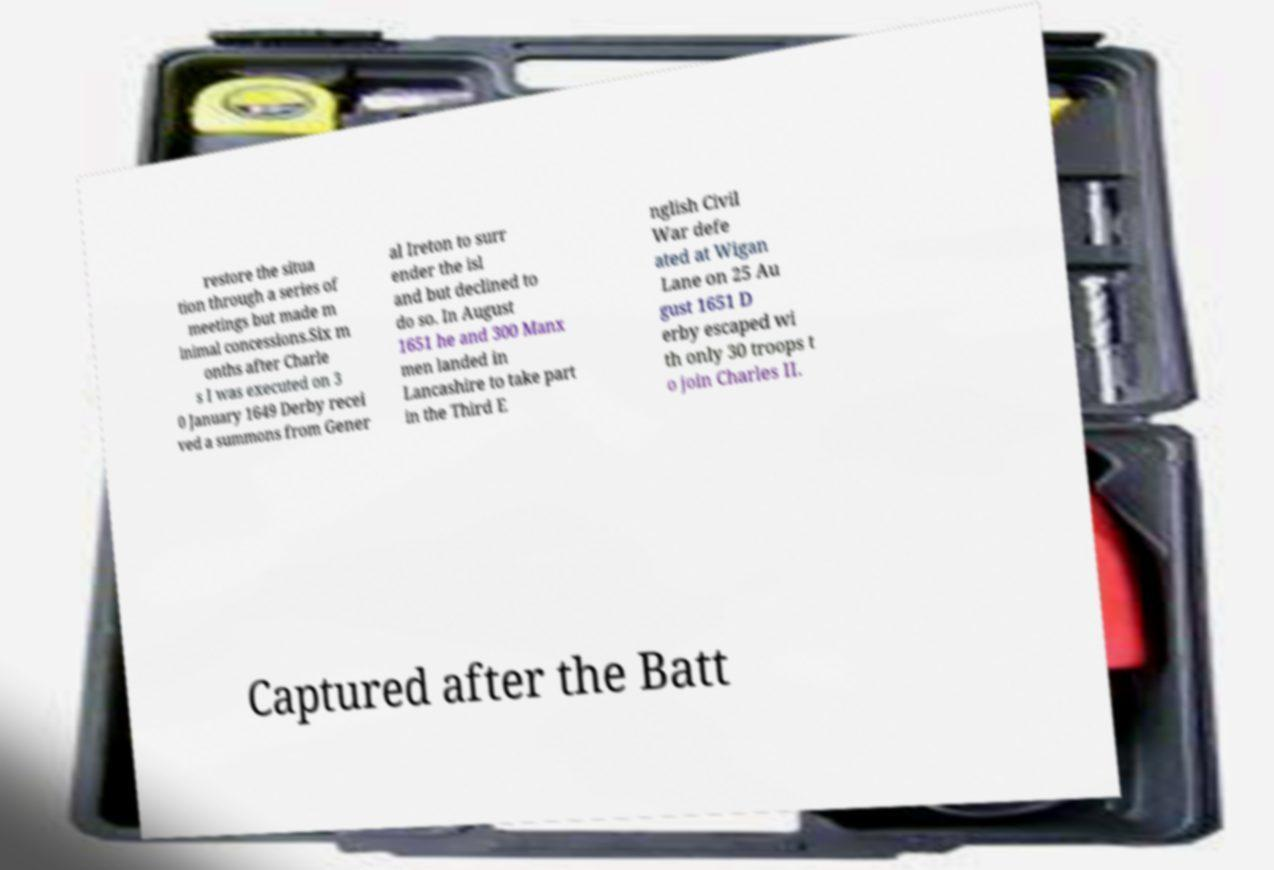Could you extract and type out the text from this image? restore the situa tion through a series of meetings but made m inimal concessions.Six m onths after Charle s I was executed on 3 0 January 1649 Derby recei ved a summons from Gener al Ireton to surr ender the isl and but declined to do so. In August 1651 he and 300 Manx men landed in Lancashire to take part in the Third E nglish Civil War defe ated at Wigan Lane on 25 Au gust 1651 D erby escaped wi th only 30 troops t o join Charles II. Captured after the Batt 